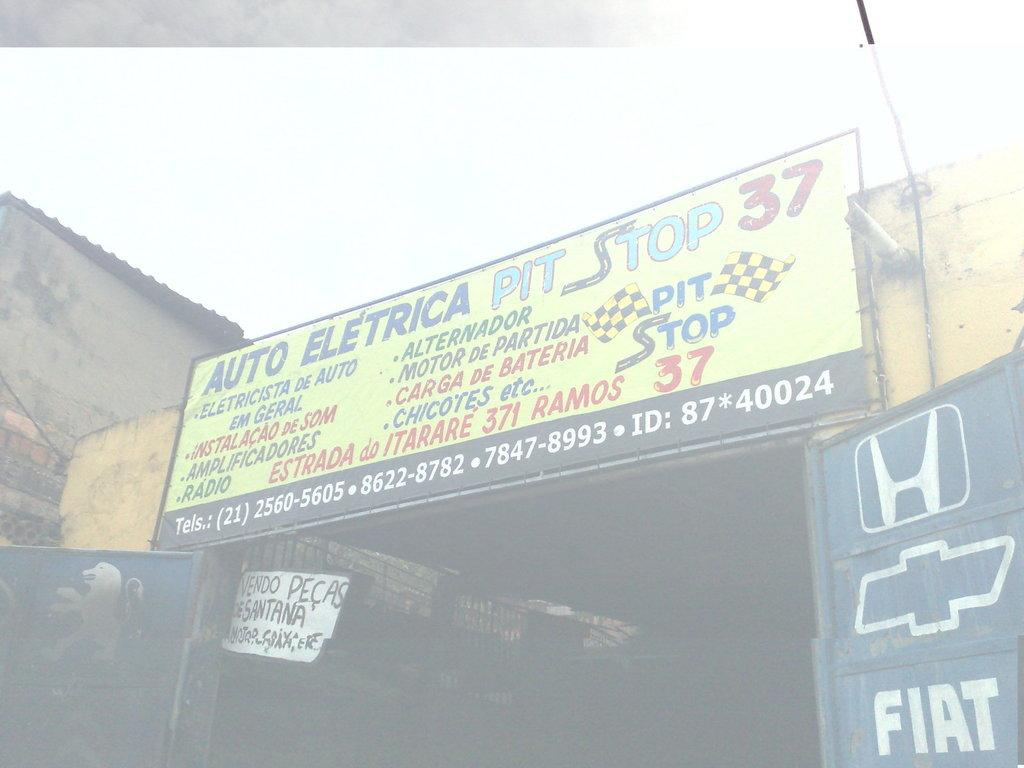<image>
Describe the image concisely. The sign for the business Auto Eletrica Pit Stop 37 shows the phone number on the bottom. 